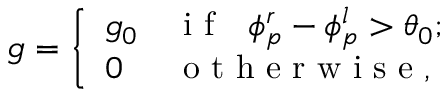Convert formula to latex. <formula><loc_0><loc_0><loc_500><loc_500>g = \left \{ \begin{array} { l l } { g _ { 0 } } & { i f \phi _ { p } ^ { r } - \phi _ { p } ^ { l } > \theta _ { 0 } ; } \\ { 0 } & { o t h e r w i s e , } \end{array}</formula> 